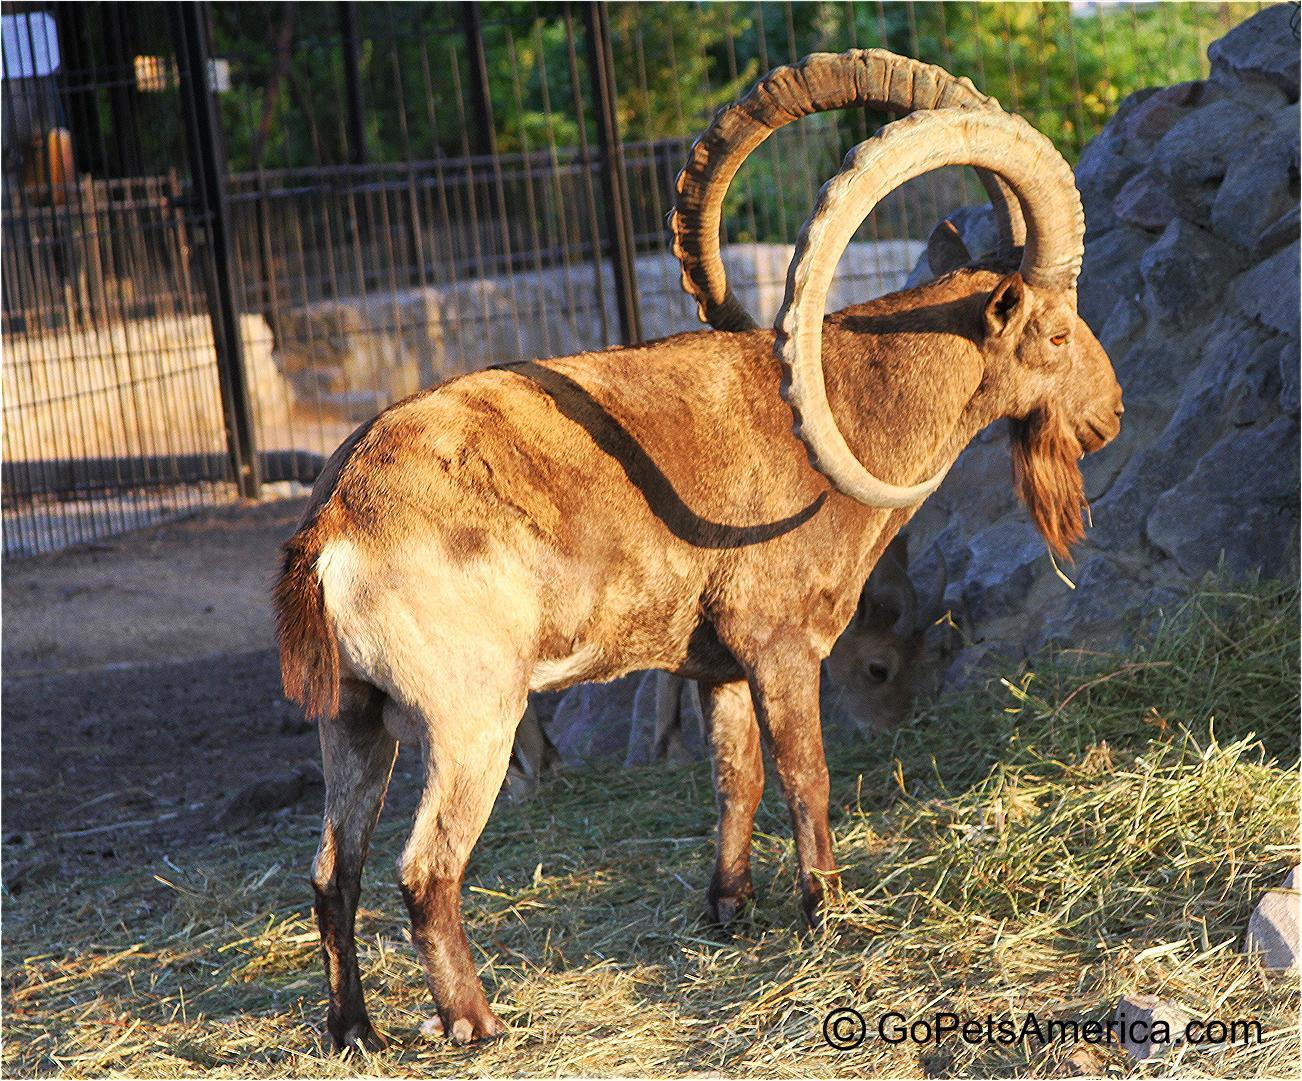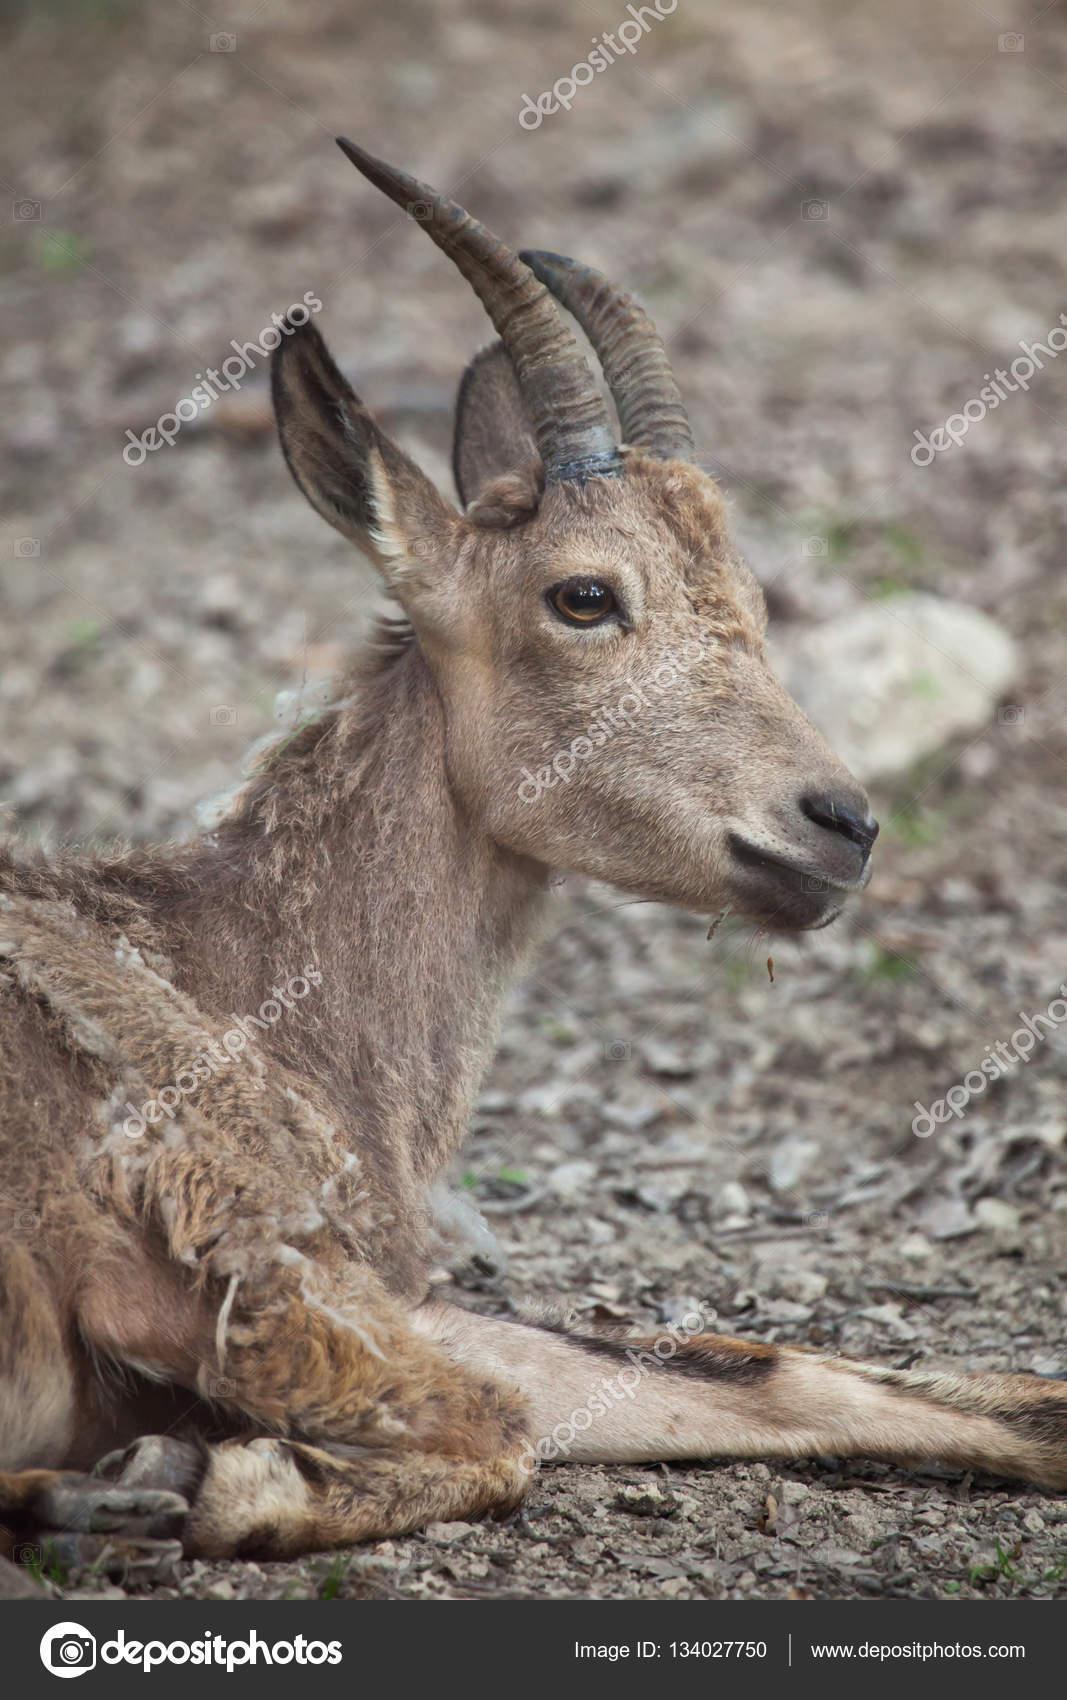The first image is the image on the left, the second image is the image on the right. For the images displayed, is the sentence "There is a total of two animals." factually correct? Answer yes or no. Yes. 